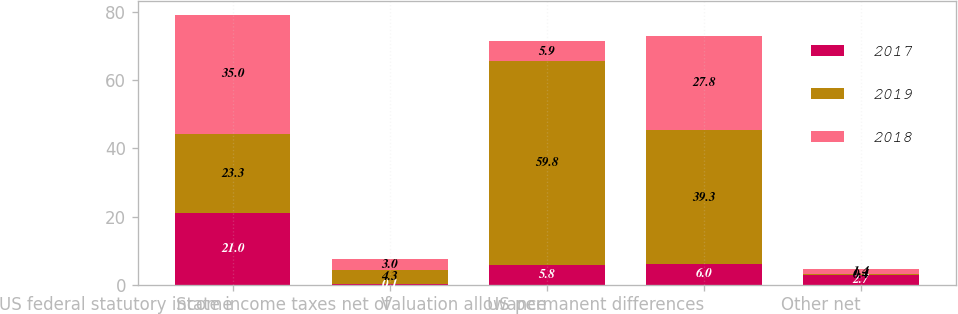Convert chart. <chart><loc_0><loc_0><loc_500><loc_500><stacked_bar_chart><ecel><fcel>US federal statutory income<fcel>State income taxes net of<fcel>Valuation allowance<fcel>US permanent differences<fcel>Other net<nl><fcel>2017<fcel>21<fcel>0.1<fcel>5.8<fcel>6<fcel>2.7<nl><fcel>2019<fcel>23.3<fcel>4.3<fcel>59.8<fcel>39.3<fcel>0.4<nl><fcel>2018<fcel>35<fcel>3<fcel>5.9<fcel>27.8<fcel>1.4<nl></chart> 